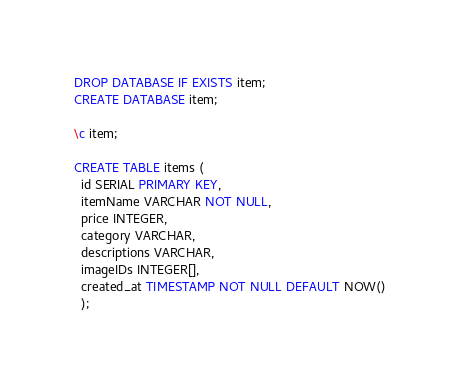<code> <loc_0><loc_0><loc_500><loc_500><_SQL_>DROP DATABASE IF EXISTS item;
CREATE DATABASE item;

\c item;

CREATE TABLE items (
  id SERIAL PRIMARY KEY,
  itemName VARCHAR NOT NULL,
  price INTEGER,
  category VARCHAR,
  descriptions VARCHAR,
  imageIDs INTEGER[],
  created_at TIMESTAMP NOT NULL DEFAULT NOW()
  );
</code> 